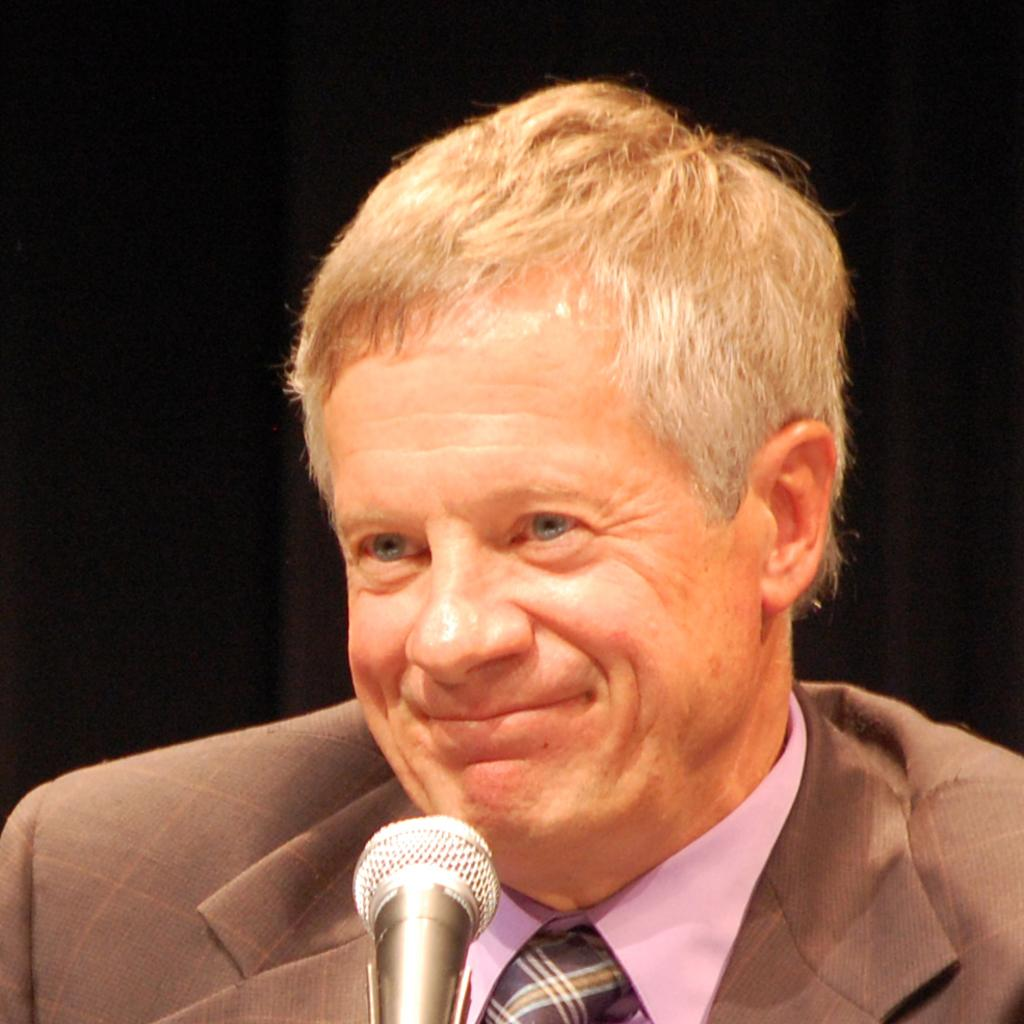Who or what is present in the image? There is a person in the image. What is the person doing or expressing? The person is smiling. What object is in front of the person? There is a microphone in front of the person. How many cats are visible in the image? There are no cats present in the image. What type of company is the person representing in the image? The image does not provide any information about the person's company or affiliation. 